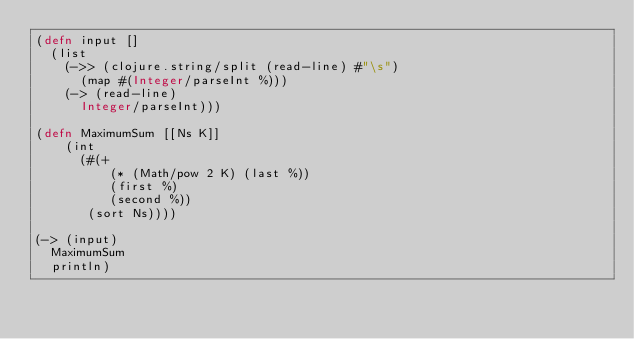Convert code to text. <code><loc_0><loc_0><loc_500><loc_500><_Clojure_>(defn input []
  (list
    (->> (clojure.string/split (read-line) #"\s")
      (map #(Integer/parseInt %)))
    (-> (read-line)
      Integer/parseInt)))

(defn MaximumSum [[Ns K]]
    (int
      (#(+
          (* (Math/pow 2 K) (last %))
          (first %)
          (second %))
       (sort Ns))))

(-> (input)
  MaximumSum
  println)</code> 